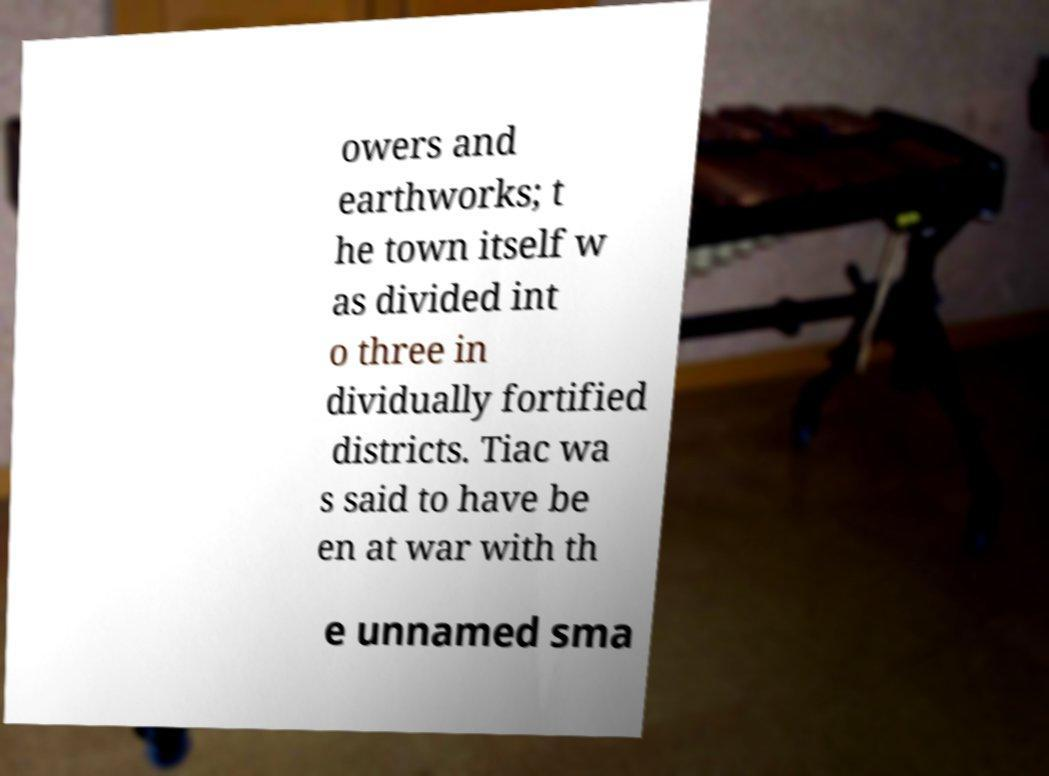Please read and relay the text visible in this image. What does it say? owers and earthworks; t he town itself w as divided int o three in dividually fortified districts. Tiac wa s said to have be en at war with th e unnamed sma 